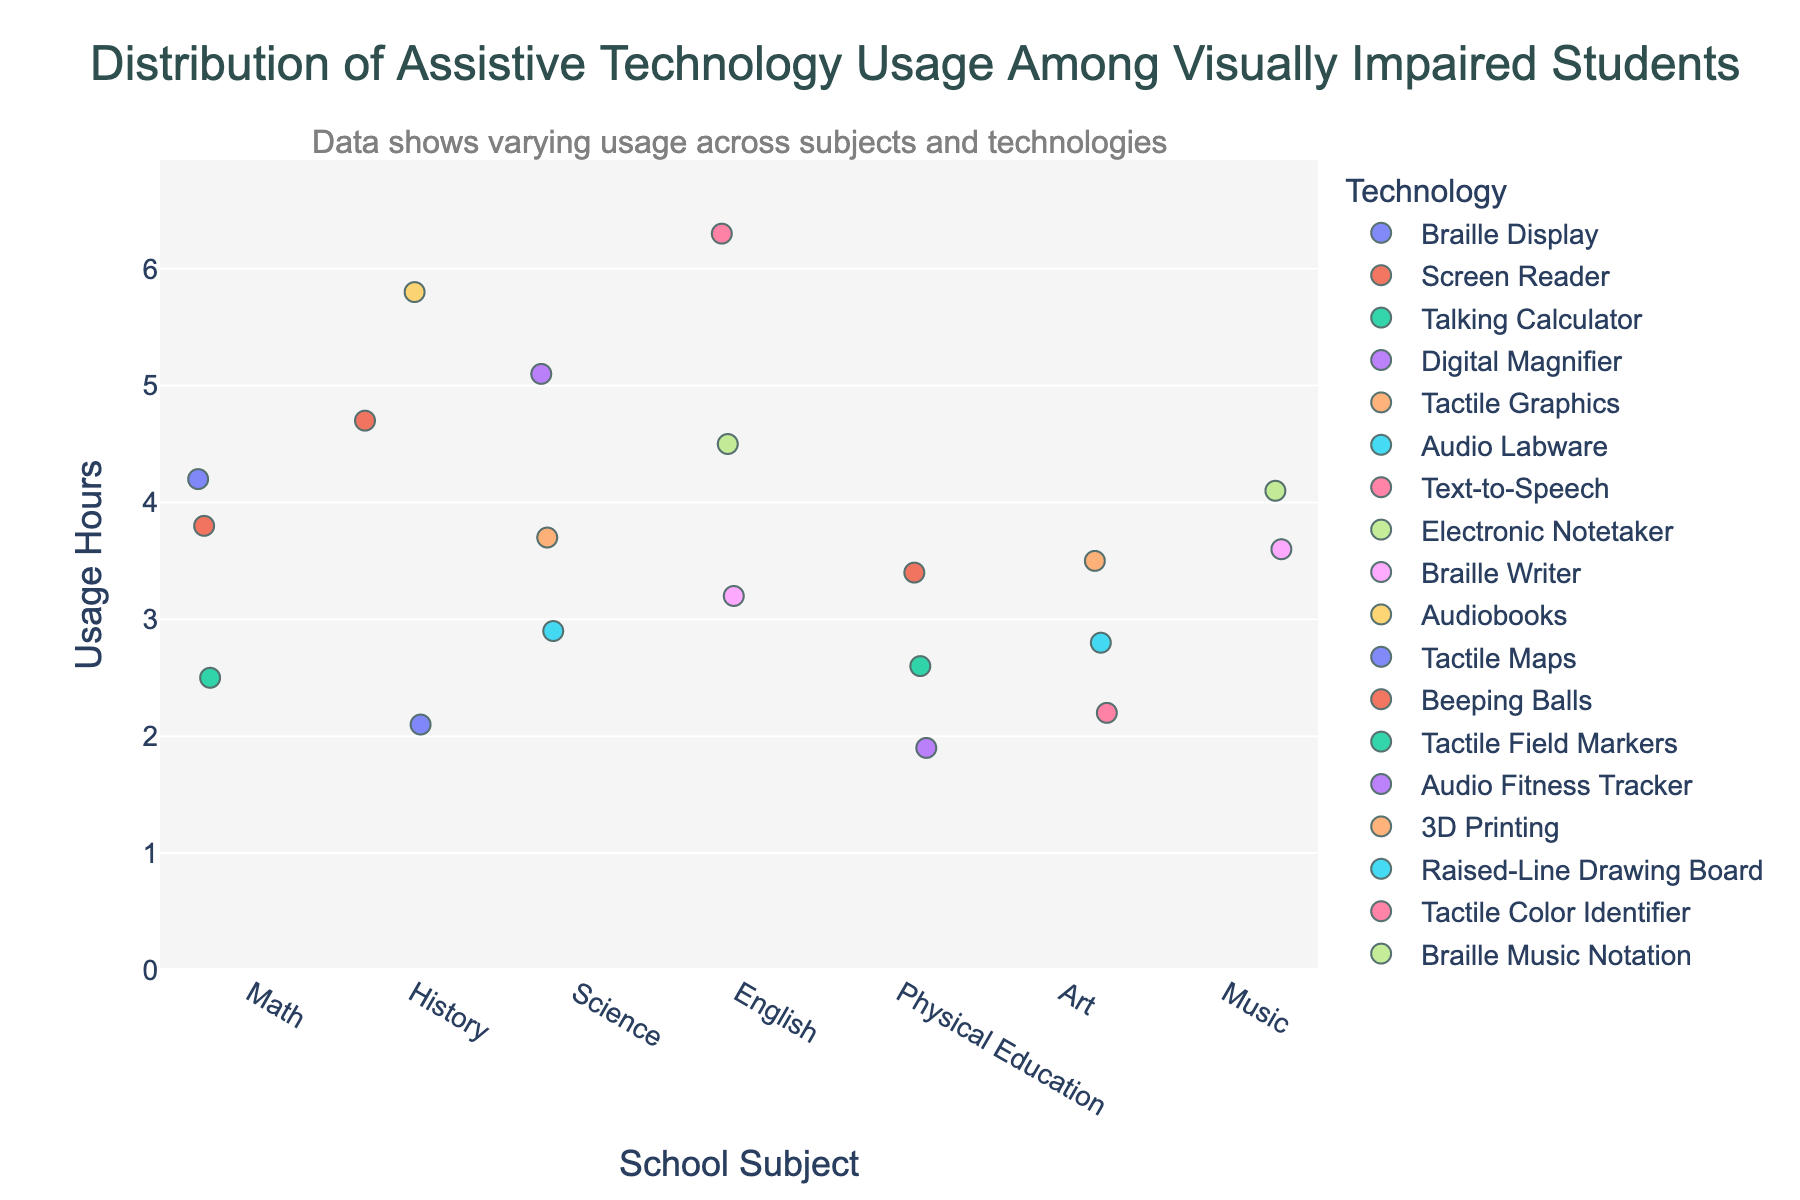What is the title of the plot? The title is usually prominently displayed at the top of the plot. In this case, the title reads "Distribution of Assistive Technology Usage Among Visually Impaired Students."
Answer: Distribution of Assistive Technology Usage Among Visually Impaired Students Which subject has the highest usage hours? To determine this, scan the vertical axis under each subject to see which has the highest value. Science has a data point reaching up to 5.1 usage hours.
Answer: Science Which technology has the highest usage hours in English? Locate the data points for English and find the highest point vertically. Text-to-Speech is at 6.3 usage hours.
Answer: Text-to-Speech How many technologies are used in the History subject? Identify the color-coded dots under History and count them. There are three technologies represented.
Answer: Three What is the range of usage hours for assistive technologies in Math? Find the least and most values for usage hours in Math. The range is from 2.5 to 4.2.
Answer: 1.7 (from 4.2 - 2.5) What is the average usage hours of assistive technology in Physical Education? Add up the usage hours for each technology in Physical Education (3.4 + 2.6 + 1.9) and divide by the number of technologies (3). The average is (3.4 + 2.6 + 1.9) / 3 = 7.9 / 3 = 2.63 hours.
Answer: 2.63 hours Which technology has the lowest usage hours in Science and what are its hours? In the Science category, identify the data point with the lowest vertical position. Audio Labware has the lowest usage hours at 2.9.
Answer: Audio Labware, 2.9 hours Compare the highest usage hours between Math and Art subjects. Which one is higher? Find the highest vertical point in both subjects and compare them. Math's highest is 4.2, while Art's highest is 3.5. Therefore, Math is higher.
Answer: Math What are the usage hours for Braille Display in Math and Electronic Notetaker in English? Match the technology names to their respective dots in Math and English. Braille Display in Math is 4.2, and Electronic Notetaker in English is 4.5.
Answer: 4.2 and 4.5 hours Which subject has the technology with the least usage hours overall, and what are those hours? Look for the lowest usage hour data point across all subjects, then identify the corresponding subject. Physical Education’s Audio Fitness Tracker has the least at 1.9 hours.
Answer: Physical Education, 1.9 hours 